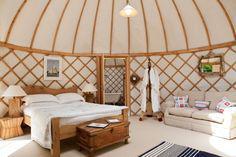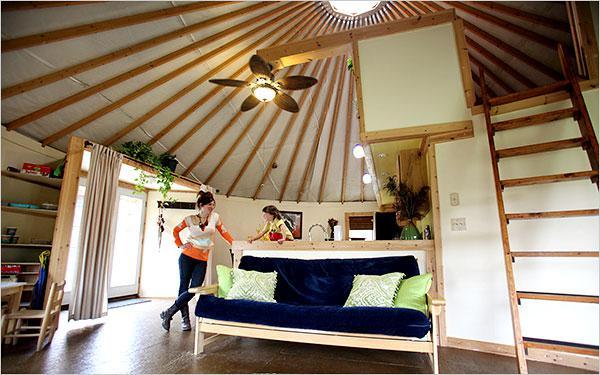The first image is the image on the left, the second image is the image on the right. For the images displayed, is the sentence "A ladder to a loft is standing at the right in an image of a yurt's interior." factually correct? Answer yes or no. Yes. The first image is the image on the left, the second image is the image on the right. Evaluate the accuracy of this statement regarding the images: "A bed sits on the ground floor of the hut in at least one of the images.". Is it true? Answer yes or no. Yes. 